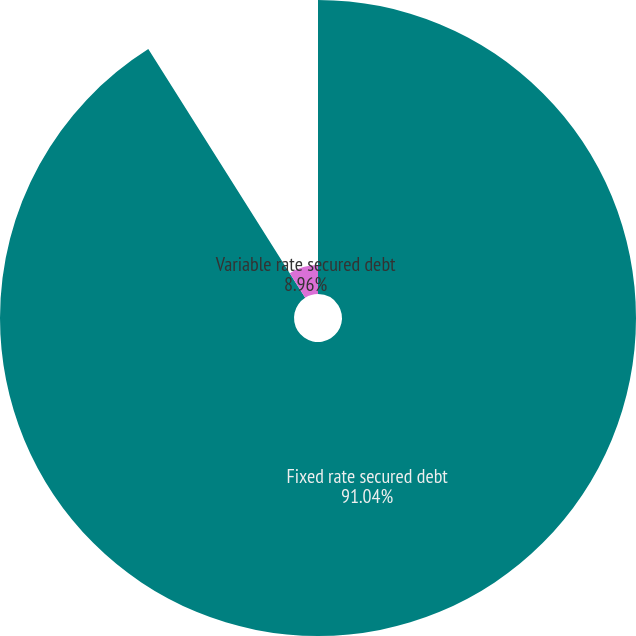Convert chart to OTSL. <chart><loc_0><loc_0><loc_500><loc_500><pie_chart><fcel>Fixed rate secured debt<fcel>Variable rate secured debt<nl><fcel>91.04%<fcel>8.96%<nl></chart> 